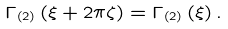Convert formula to latex. <formula><loc_0><loc_0><loc_500><loc_500>\Gamma _ { \left ( 2 \right ) } \left ( \xi + 2 \pi \zeta \right ) = \Gamma _ { \left ( 2 \right ) } \left ( \xi \right ) .</formula> 